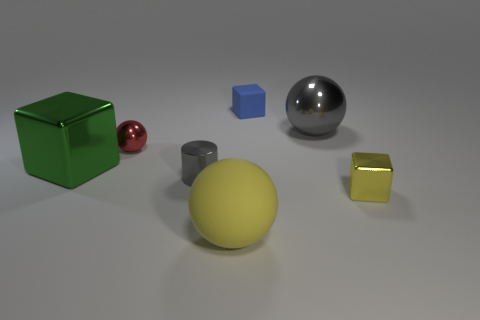Add 1 green objects. How many objects exist? 8 Subtract all blocks. How many objects are left? 4 Add 2 big rubber balls. How many big rubber balls are left? 3 Add 3 tiny cyan metallic balls. How many tiny cyan metallic balls exist? 3 Subtract 0 red cylinders. How many objects are left? 7 Subtract all big blocks. Subtract all green things. How many objects are left? 5 